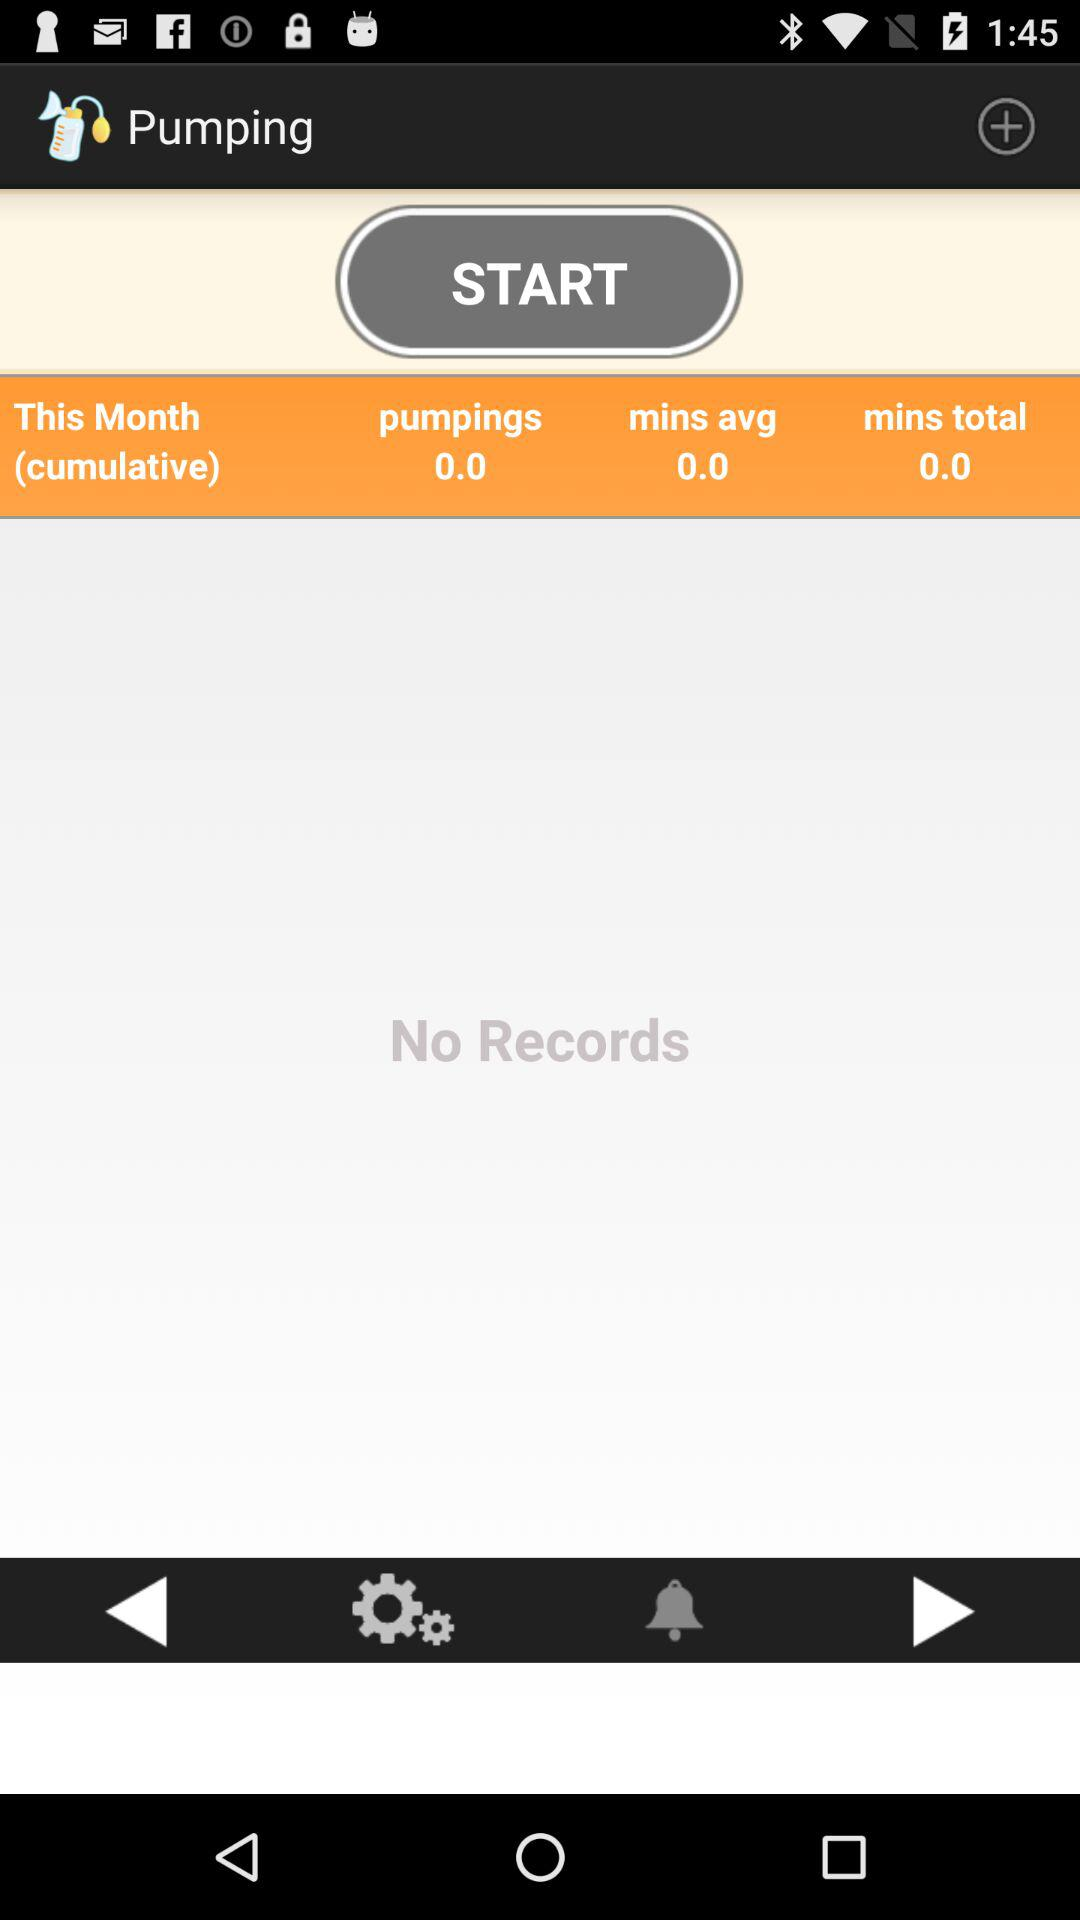What is the "mins total" of "Pumping" this month? The "mins total" of "Pumping" this month is 0.0. 